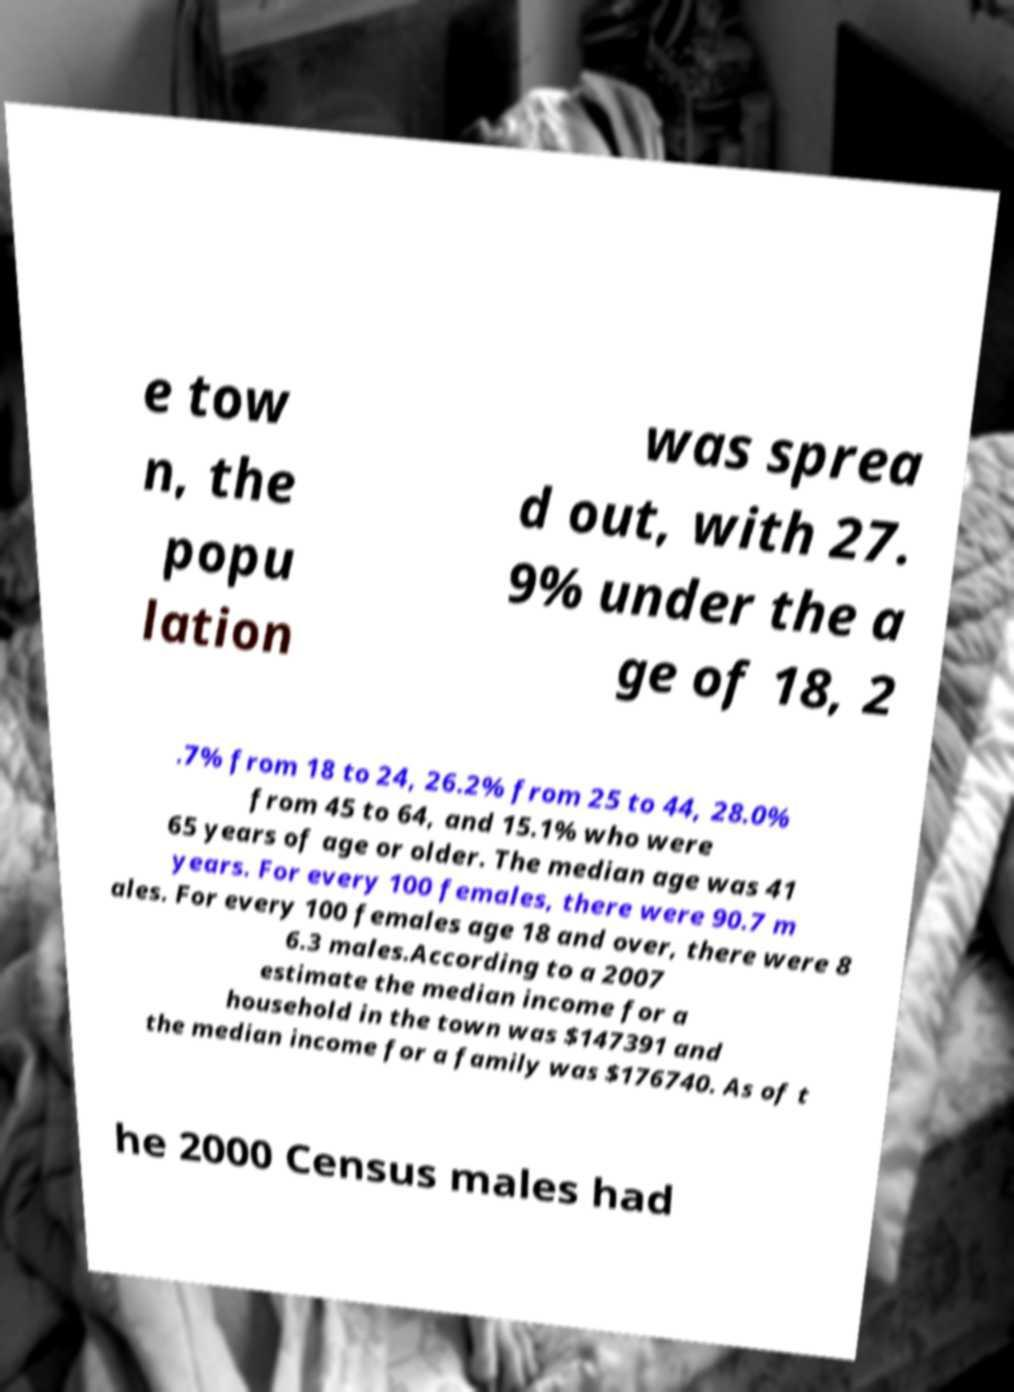There's text embedded in this image that I need extracted. Can you transcribe it verbatim? e tow n, the popu lation was sprea d out, with 27. 9% under the a ge of 18, 2 .7% from 18 to 24, 26.2% from 25 to 44, 28.0% from 45 to 64, and 15.1% who were 65 years of age or older. The median age was 41 years. For every 100 females, there were 90.7 m ales. For every 100 females age 18 and over, there were 8 6.3 males.According to a 2007 estimate the median income for a household in the town was $147391 and the median income for a family was $176740. As of t he 2000 Census males had 